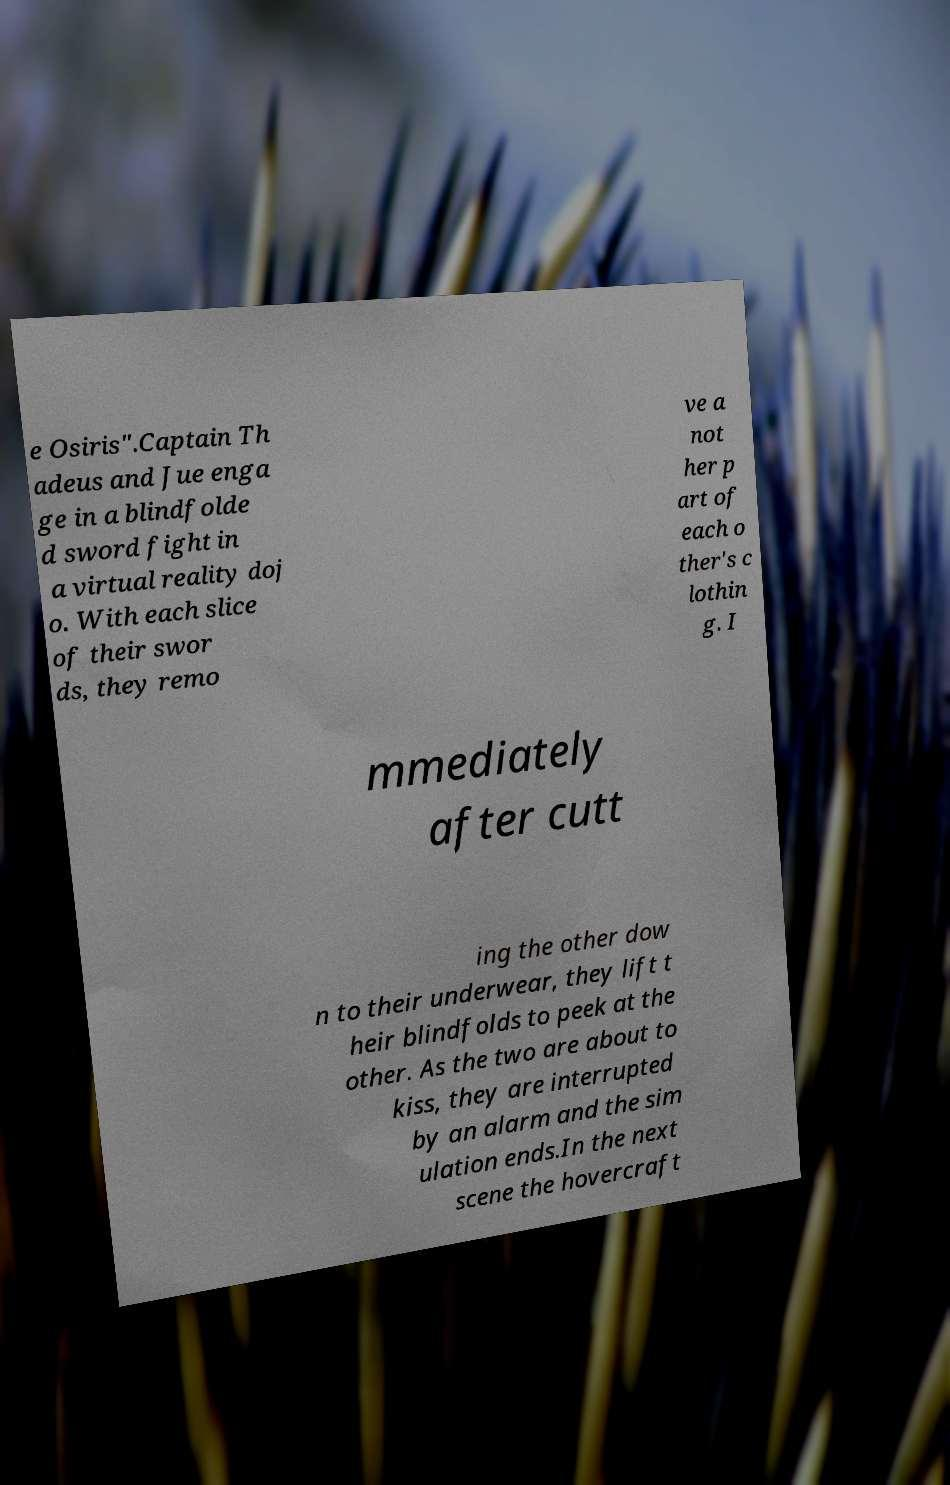What messages or text are displayed in this image? I need them in a readable, typed format. e Osiris".Captain Th adeus and Jue enga ge in a blindfolde d sword fight in a virtual reality doj o. With each slice of their swor ds, they remo ve a not her p art of each o ther's c lothin g. I mmediately after cutt ing the other dow n to their underwear, they lift t heir blindfolds to peek at the other. As the two are about to kiss, they are interrupted by an alarm and the sim ulation ends.In the next scene the hovercraft 